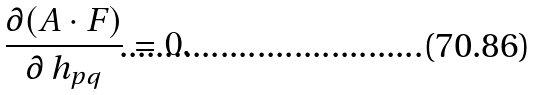<formula> <loc_0><loc_0><loc_500><loc_500>\frac { \partial ( A \cdot F ) } { \partial \, h _ { p q } } = 0 .</formula> 